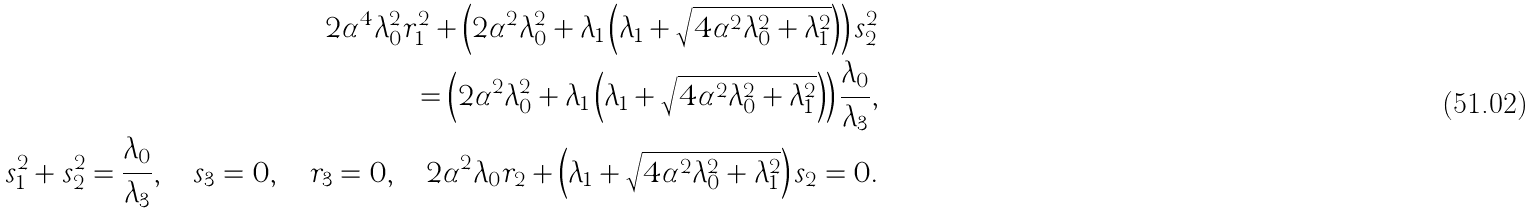<formula> <loc_0><loc_0><loc_500><loc_500>2 \alpha ^ { 4 } \lambda _ { 0 } ^ { 2 } r _ { 1 } ^ { 2 } + \left ( 2 \alpha ^ { 2 } \lambda _ { 0 } ^ { 2 } + \lambda _ { 1 } \left ( \lambda _ { 1 } + \sqrt { 4 \alpha ^ { 2 } \lambda _ { 0 } ^ { 2 } + \lambda _ { 1 } ^ { 2 } } \right ) \right ) s _ { 2 } ^ { 2 } \\ = \left ( 2 \alpha ^ { 2 } \lambda _ { 0 } ^ { 2 } + \lambda _ { 1 } \left ( \lambda _ { 1 } + \sqrt { 4 \alpha ^ { 2 } \lambda _ { 0 } ^ { 2 } + \lambda _ { 1 } ^ { 2 } } \right ) \right ) \frac { \lambda _ { 0 } } { \lambda _ { 3 } } , \\ s _ { 1 } ^ { 2 } + s _ { 2 } ^ { 2 } = \frac { \lambda _ { 0 } } { \lambda _ { 3 } } , \quad s _ { 3 } = 0 , \quad r _ { 3 } = 0 , \quad 2 \alpha ^ { 2 } \lambda _ { 0 } r _ { 2 } + \left ( \lambda _ { 1 } + \sqrt { 4 \alpha ^ { 2 } \lambda _ { 0 } ^ { 2 } + \lambda _ { 1 } ^ { 2 } } \right ) s _ { 2 } = 0 .</formula> 